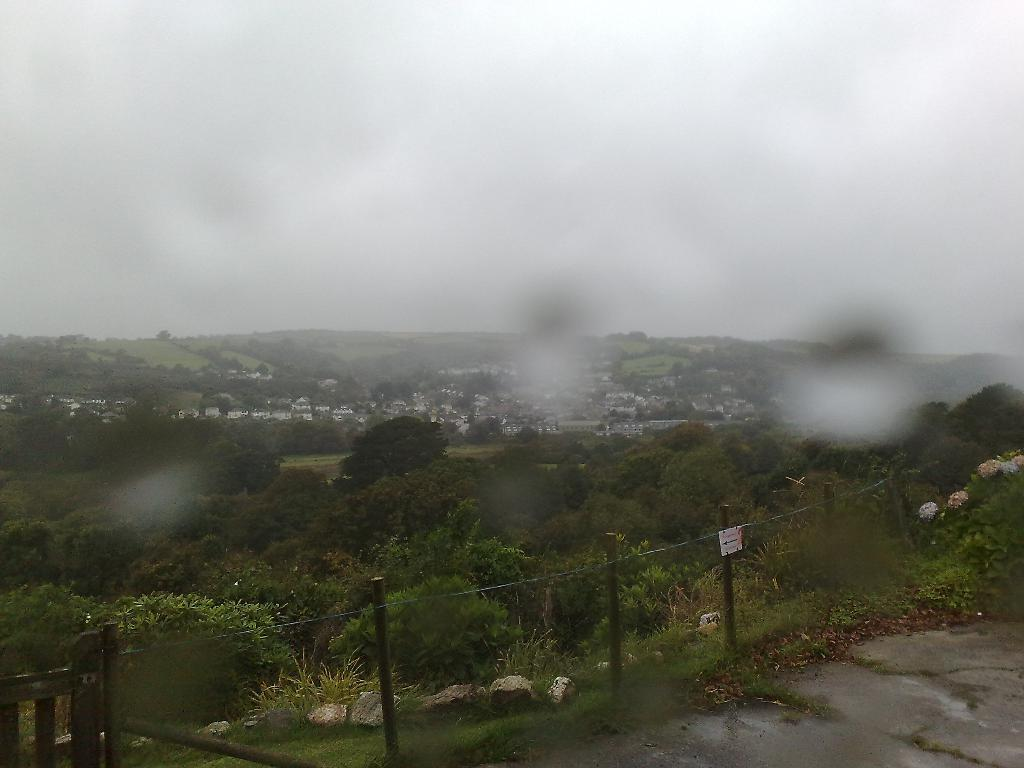What type of barrier can be seen in the image? There is a fence in the image. What natural elements are present in the image? There are rocks and trees in the image. What type of structures can be seen in the background of the image? There are buildings in the background of the image. Where is the hydrant located in the image? There is no hydrant present in the image. What type of animal can be seen interacting with the rocks in the image? There are no animals present in the image; it features a fence, rocks, trees, and buildings. 